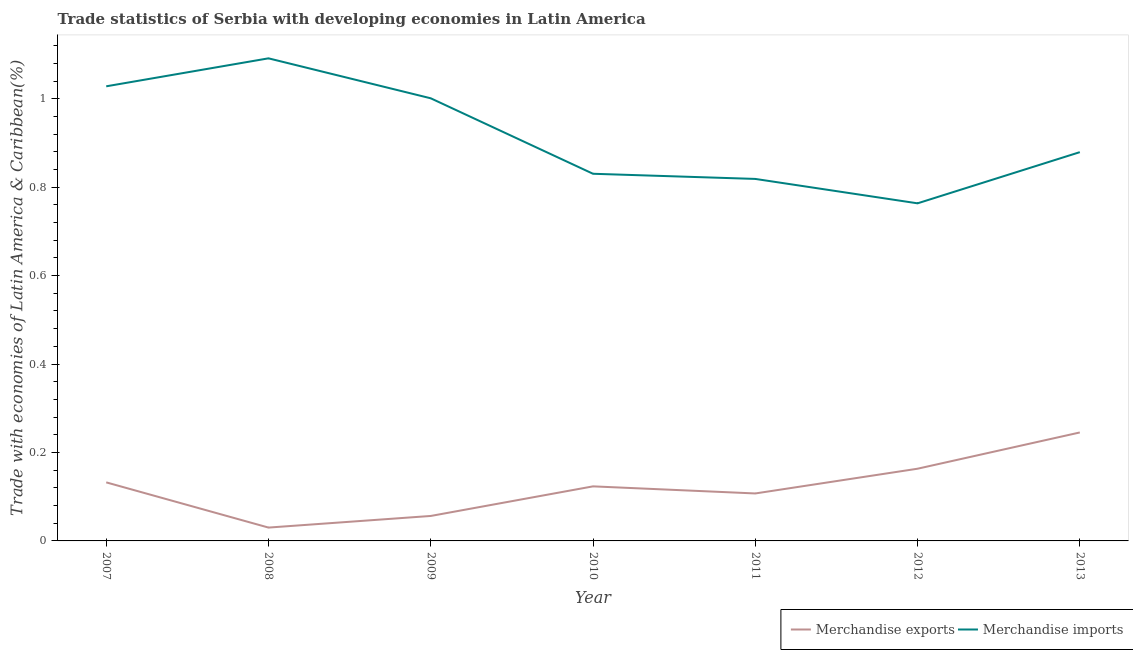Does the line corresponding to merchandise exports intersect with the line corresponding to merchandise imports?
Your response must be concise. No. Is the number of lines equal to the number of legend labels?
Offer a very short reply. Yes. What is the merchandise imports in 2007?
Offer a very short reply. 1.03. Across all years, what is the maximum merchandise exports?
Your answer should be very brief. 0.25. Across all years, what is the minimum merchandise exports?
Make the answer very short. 0.03. In which year was the merchandise imports minimum?
Your answer should be very brief. 2012. What is the total merchandise imports in the graph?
Make the answer very short. 6.41. What is the difference between the merchandise exports in 2011 and that in 2013?
Offer a terse response. -0.14. What is the difference between the merchandise exports in 2013 and the merchandise imports in 2011?
Provide a short and direct response. -0.57. What is the average merchandise exports per year?
Ensure brevity in your answer.  0.12. In the year 2007, what is the difference between the merchandise exports and merchandise imports?
Ensure brevity in your answer.  -0.9. What is the ratio of the merchandise imports in 2010 to that in 2011?
Ensure brevity in your answer.  1.01. What is the difference between the highest and the second highest merchandise exports?
Give a very brief answer. 0.08. What is the difference between the highest and the lowest merchandise imports?
Your answer should be very brief. 0.33. Does the merchandise exports monotonically increase over the years?
Provide a short and direct response. No. Is the merchandise imports strictly greater than the merchandise exports over the years?
Make the answer very short. Yes. Is the merchandise exports strictly less than the merchandise imports over the years?
Offer a very short reply. Yes. How many lines are there?
Provide a short and direct response. 2. How are the legend labels stacked?
Keep it short and to the point. Horizontal. What is the title of the graph?
Make the answer very short. Trade statistics of Serbia with developing economies in Latin America. Does "Net National savings" appear as one of the legend labels in the graph?
Offer a very short reply. No. What is the label or title of the Y-axis?
Provide a succinct answer. Trade with economies of Latin America & Caribbean(%). What is the Trade with economies of Latin America & Caribbean(%) of Merchandise exports in 2007?
Make the answer very short. 0.13. What is the Trade with economies of Latin America & Caribbean(%) in Merchandise imports in 2007?
Offer a terse response. 1.03. What is the Trade with economies of Latin America & Caribbean(%) of Merchandise exports in 2008?
Offer a terse response. 0.03. What is the Trade with economies of Latin America & Caribbean(%) in Merchandise imports in 2008?
Your answer should be very brief. 1.09. What is the Trade with economies of Latin America & Caribbean(%) of Merchandise exports in 2009?
Give a very brief answer. 0.06. What is the Trade with economies of Latin America & Caribbean(%) of Merchandise imports in 2009?
Give a very brief answer. 1. What is the Trade with economies of Latin America & Caribbean(%) of Merchandise exports in 2010?
Your answer should be compact. 0.12. What is the Trade with economies of Latin America & Caribbean(%) in Merchandise imports in 2010?
Ensure brevity in your answer.  0.83. What is the Trade with economies of Latin America & Caribbean(%) of Merchandise exports in 2011?
Ensure brevity in your answer.  0.11. What is the Trade with economies of Latin America & Caribbean(%) in Merchandise imports in 2011?
Keep it short and to the point. 0.82. What is the Trade with economies of Latin America & Caribbean(%) in Merchandise exports in 2012?
Provide a short and direct response. 0.16. What is the Trade with economies of Latin America & Caribbean(%) in Merchandise imports in 2012?
Your answer should be compact. 0.76. What is the Trade with economies of Latin America & Caribbean(%) in Merchandise exports in 2013?
Ensure brevity in your answer.  0.25. What is the Trade with economies of Latin America & Caribbean(%) in Merchandise imports in 2013?
Give a very brief answer. 0.88. Across all years, what is the maximum Trade with economies of Latin America & Caribbean(%) in Merchandise exports?
Your answer should be compact. 0.25. Across all years, what is the maximum Trade with economies of Latin America & Caribbean(%) in Merchandise imports?
Give a very brief answer. 1.09. Across all years, what is the minimum Trade with economies of Latin America & Caribbean(%) in Merchandise exports?
Provide a succinct answer. 0.03. Across all years, what is the minimum Trade with economies of Latin America & Caribbean(%) of Merchandise imports?
Offer a terse response. 0.76. What is the total Trade with economies of Latin America & Caribbean(%) of Merchandise exports in the graph?
Offer a terse response. 0.86. What is the total Trade with economies of Latin America & Caribbean(%) in Merchandise imports in the graph?
Ensure brevity in your answer.  6.41. What is the difference between the Trade with economies of Latin America & Caribbean(%) of Merchandise exports in 2007 and that in 2008?
Your response must be concise. 0.1. What is the difference between the Trade with economies of Latin America & Caribbean(%) of Merchandise imports in 2007 and that in 2008?
Your response must be concise. -0.06. What is the difference between the Trade with economies of Latin America & Caribbean(%) in Merchandise exports in 2007 and that in 2009?
Provide a succinct answer. 0.08. What is the difference between the Trade with economies of Latin America & Caribbean(%) in Merchandise imports in 2007 and that in 2009?
Offer a very short reply. 0.03. What is the difference between the Trade with economies of Latin America & Caribbean(%) in Merchandise exports in 2007 and that in 2010?
Provide a succinct answer. 0.01. What is the difference between the Trade with economies of Latin America & Caribbean(%) in Merchandise imports in 2007 and that in 2010?
Offer a terse response. 0.2. What is the difference between the Trade with economies of Latin America & Caribbean(%) of Merchandise exports in 2007 and that in 2011?
Provide a succinct answer. 0.03. What is the difference between the Trade with economies of Latin America & Caribbean(%) of Merchandise imports in 2007 and that in 2011?
Your answer should be compact. 0.21. What is the difference between the Trade with economies of Latin America & Caribbean(%) in Merchandise exports in 2007 and that in 2012?
Offer a very short reply. -0.03. What is the difference between the Trade with economies of Latin America & Caribbean(%) of Merchandise imports in 2007 and that in 2012?
Offer a very short reply. 0.26. What is the difference between the Trade with economies of Latin America & Caribbean(%) of Merchandise exports in 2007 and that in 2013?
Make the answer very short. -0.11. What is the difference between the Trade with economies of Latin America & Caribbean(%) of Merchandise imports in 2007 and that in 2013?
Provide a succinct answer. 0.15. What is the difference between the Trade with economies of Latin America & Caribbean(%) in Merchandise exports in 2008 and that in 2009?
Provide a succinct answer. -0.03. What is the difference between the Trade with economies of Latin America & Caribbean(%) in Merchandise imports in 2008 and that in 2009?
Offer a terse response. 0.09. What is the difference between the Trade with economies of Latin America & Caribbean(%) in Merchandise exports in 2008 and that in 2010?
Your answer should be compact. -0.09. What is the difference between the Trade with economies of Latin America & Caribbean(%) of Merchandise imports in 2008 and that in 2010?
Your answer should be compact. 0.26. What is the difference between the Trade with economies of Latin America & Caribbean(%) of Merchandise exports in 2008 and that in 2011?
Your response must be concise. -0.08. What is the difference between the Trade with economies of Latin America & Caribbean(%) in Merchandise imports in 2008 and that in 2011?
Provide a short and direct response. 0.27. What is the difference between the Trade with economies of Latin America & Caribbean(%) in Merchandise exports in 2008 and that in 2012?
Provide a succinct answer. -0.13. What is the difference between the Trade with economies of Latin America & Caribbean(%) of Merchandise imports in 2008 and that in 2012?
Your answer should be compact. 0.33. What is the difference between the Trade with economies of Latin America & Caribbean(%) in Merchandise exports in 2008 and that in 2013?
Offer a terse response. -0.22. What is the difference between the Trade with economies of Latin America & Caribbean(%) of Merchandise imports in 2008 and that in 2013?
Ensure brevity in your answer.  0.21. What is the difference between the Trade with economies of Latin America & Caribbean(%) of Merchandise exports in 2009 and that in 2010?
Ensure brevity in your answer.  -0.07. What is the difference between the Trade with economies of Latin America & Caribbean(%) in Merchandise imports in 2009 and that in 2010?
Provide a short and direct response. 0.17. What is the difference between the Trade with economies of Latin America & Caribbean(%) of Merchandise exports in 2009 and that in 2011?
Provide a short and direct response. -0.05. What is the difference between the Trade with economies of Latin America & Caribbean(%) in Merchandise imports in 2009 and that in 2011?
Make the answer very short. 0.18. What is the difference between the Trade with economies of Latin America & Caribbean(%) in Merchandise exports in 2009 and that in 2012?
Offer a very short reply. -0.11. What is the difference between the Trade with economies of Latin America & Caribbean(%) of Merchandise imports in 2009 and that in 2012?
Give a very brief answer. 0.24. What is the difference between the Trade with economies of Latin America & Caribbean(%) of Merchandise exports in 2009 and that in 2013?
Your answer should be compact. -0.19. What is the difference between the Trade with economies of Latin America & Caribbean(%) of Merchandise imports in 2009 and that in 2013?
Keep it short and to the point. 0.12. What is the difference between the Trade with economies of Latin America & Caribbean(%) in Merchandise exports in 2010 and that in 2011?
Your answer should be compact. 0.02. What is the difference between the Trade with economies of Latin America & Caribbean(%) in Merchandise imports in 2010 and that in 2011?
Your answer should be compact. 0.01. What is the difference between the Trade with economies of Latin America & Caribbean(%) in Merchandise exports in 2010 and that in 2012?
Keep it short and to the point. -0.04. What is the difference between the Trade with economies of Latin America & Caribbean(%) of Merchandise imports in 2010 and that in 2012?
Provide a succinct answer. 0.07. What is the difference between the Trade with economies of Latin America & Caribbean(%) in Merchandise exports in 2010 and that in 2013?
Your answer should be very brief. -0.12. What is the difference between the Trade with economies of Latin America & Caribbean(%) in Merchandise imports in 2010 and that in 2013?
Offer a terse response. -0.05. What is the difference between the Trade with economies of Latin America & Caribbean(%) in Merchandise exports in 2011 and that in 2012?
Provide a short and direct response. -0.06. What is the difference between the Trade with economies of Latin America & Caribbean(%) in Merchandise imports in 2011 and that in 2012?
Your response must be concise. 0.06. What is the difference between the Trade with economies of Latin America & Caribbean(%) of Merchandise exports in 2011 and that in 2013?
Keep it short and to the point. -0.14. What is the difference between the Trade with economies of Latin America & Caribbean(%) of Merchandise imports in 2011 and that in 2013?
Offer a terse response. -0.06. What is the difference between the Trade with economies of Latin America & Caribbean(%) of Merchandise exports in 2012 and that in 2013?
Keep it short and to the point. -0.08. What is the difference between the Trade with economies of Latin America & Caribbean(%) of Merchandise imports in 2012 and that in 2013?
Your response must be concise. -0.12. What is the difference between the Trade with economies of Latin America & Caribbean(%) in Merchandise exports in 2007 and the Trade with economies of Latin America & Caribbean(%) in Merchandise imports in 2008?
Make the answer very short. -0.96. What is the difference between the Trade with economies of Latin America & Caribbean(%) of Merchandise exports in 2007 and the Trade with economies of Latin America & Caribbean(%) of Merchandise imports in 2009?
Provide a short and direct response. -0.87. What is the difference between the Trade with economies of Latin America & Caribbean(%) of Merchandise exports in 2007 and the Trade with economies of Latin America & Caribbean(%) of Merchandise imports in 2010?
Ensure brevity in your answer.  -0.7. What is the difference between the Trade with economies of Latin America & Caribbean(%) of Merchandise exports in 2007 and the Trade with economies of Latin America & Caribbean(%) of Merchandise imports in 2011?
Offer a very short reply. -0.69. What is the difference between the Trade with economies of Latin America & Caribbean(%) in Merchandise exports in 2007 and the Trade with economies of Latin America & Caribbean(%) in Merchandise imports in 2012?
Your answer should be very brief. -0.63. What is the difference between the Trade with economies of Latin America & Caribbean(%) of Merchandise exports in 2007 and the Trade with economies of Latin America & Caribbean(%) of Merchandise imports in 2013?
Your response must be concise. -0.75. What is the difference between the Trade with economies of Latin America & Caribbean(%) in Merchandise exports in 2008 and the Trade with economies of Latin America & Caribbean(%) in Merchandise imports in 2009?
Your answer should be very brief. -0.97. What is the difference between the Trade with economies of Latin America & Caribbean(%) of Merchandise exports in 2008 and the Trade with economies of Latin America & Caribbean(%) of Merchandise imports in 2010?
Make the answer very short. -0.8. What is the difference between the Trade with economies of Latin America & Caribbean(%) of Merchandise exports in 2008 and the Trade with economies of Latin America & Caribbean(%) of Merchandise imports in 2011?
Ensure brevity in your answer.  -0.79. What is the difference between the Trade with economies of Latin America & Caribbean(%) in Merchandise exports in 2008 and the Trade with economies of Latin America & Caribbean(%) in Merchandise imports in 2012?
Your answer should be very brief. -0.73. What is the difference between the Trade with economies of Latin America & Caribbean(%) in Merchandise exports in 2008 and the Trade with economies of Latin America & Caribbean(%) in Merchandise imports in 2013?
Give a very brief answer. -0.85. What is the difference between the Trade with economies of Latin America & Caribbean(%) of Merchandise exports in 2009 and the Trade with economies of Latin America & Caribbean(%) of Merchandise imports in 2010?
Make the answer very short. -0.77. What is the difference between the Trade with economies of Latin America & Caribbean(%) in Merchandise exports in 2009 and the Trade with economies of Latin America & Caribbean(%) in Merchandise imports in 2011?
Ensure brevity in your answer.  -0.76. What is the difference between the Trade with economies of Latin America & Caribbean(%) in Merchandise exports in 2009 and the Trade with economies of Latin America & Caribbean(%) in Merchandise imports in 2012?
Provide a succinct answer. -0.71. What is the difference between the Trade with economies of Latin America & Caribbean(%) in Merchandise exports in 2009 and the Trade with economies of Latin America & Caribbean(%) in Merchandise imports in 2013?
Your answer should be very brief. -0.82. What is the difference between the Trade with economies of Latin America & Caribbean(%) in Merchandise exports in 2010 and the Trade with economies of Latin America & Caribbean(%) in Merchandise imports in 2011?
Make the answer very short. -0.7. What is the difference between the Trade with economies of Latin America & Caribbean(%) of Merchandise exports in 2010 and the Trade with economies of Latin America & Caribbean(%) of Merchandise imports in 2012?
Keep it short and to the point. -0.64. What is the difference between the Trade with economies of Latin America & Caribbean(%) of Merchandise exports in 2010 and the Trade with economies of Latin America & Caribbean(%) of Merchandise imports in 2013?
Your response must be concise. -0.76. What is the difference between the Trade with economies of Latin America & Caribbean(%) of Merchandise exports in 2011 and the Trade with economies of Latin America & Caribbean(%) of Merchandise imports in 2012?
Provide a succinct answer. -0.66. What is the difference between the Trade with economies of Latin America & Caribbean(%) of Merchandise exports in 2011 and the Trade with economies of Latin America & Caribbean(%) of Merchandise imports in 2013?
Your response must be concise. -0.77. What is the difference between the Trade with economies of Latin America & Caribbean(%) of Merchandise exports in 2012 and the Trade with economies of Latin America & Caribbean(%) of Merchandise imports in 2013?
Ensure brevity in your answer.  -0.72. What is the average Trade with economies of Latin America & Caribbean(%) in Merchandise exports per year?
Offer a terse response. 0.12. What is the average Trade with economies of Latin America & Caribbean(%) of Merchandise imports per year?
Offer a very short reply. 0.92. In the year 2007, what is the difference between the Trade with economies of Latin America & Caribbean(%) of Merchandise exports and Trade with economies of Latin America & Caribbean(%) of Merchandise imports?
Provide a short and direct response. -0.9. In the year 2008, what is the difference between the Trade with economies of Latin America & Caribbean(%) of Merchandise exports and Trade with economies of Latin America & Caribbean(%) of Merchandise imports?
Your answer should be very brief. -1.06. In the year 2009, what is the difference between the Trade with economies of Latin America & Caribbean(%) in Merchandise exports and Trade with economies of Latin America & Caribbean(%) in Merchandise imports?
Offer a terse response. -0.94. In the year 2010, what is the difference between the Trade with economies of Latin America & Caribbean(%) in Merchandise exports and Trade with economies of Latin America & Caribbean(%) in Merchandise imports?
Your response must be concise. -0.71. In the year 2011, what is the difference between the Trade with economies of Latin America & Caribbean(%) in Merchandise exports and Trade with economies of Latin America & Caribbean(%) in Merchandise imports?
Provide a short and direct response. -0.71. In the year 2012, what is the difference between the Trade with economies of Latin America & Caribbean(%) in Merchandise exports and Trade with economies of Latin America & Caribbean(%) in Merchandise imports?
Give a very brief answer. -0.6. In the year 2013, what is the difference between the Trade with economies of Latin America & Caribbean(%) in Merchandise exports and Trade with economies of Latin America & Caribbean(%) in Merchandise imports?
Offer a terse response. -0.63. What is the ratio of the Trade with economies of Latin America & Caribbean(%) in Merchandise exports in 2007 to that in 2008?
Your response must be concise. 4.39. What is the ratio of the Trade with economies of Latin America & Caribbean(%) of Merchandise imports in 2007 to that in 2008?
Offer a very short reply. 0.94. What is the ratio of the Trade with economies of Latin America & Caribbean(%) in Merchandise exports in 2007 to that in 2009?
Your response must be concise. 2.35. What is the ratio of the Trade with economies of Latin America & Caribbean(%) of Merchandise imports in 2007 to that in 2009?
Your response must be concise. 1.03. What is the ratio of the Trade with economies of Latin America & Caribbean(%) of Merchandise exports in 2007 to that in 2010?
Give a very brief answer. 1.07. What is the ratio of the Trade with economies of Latin America & Caribbean(%) in Merchandise imports in 2007 to that in 2010?
Give a very brief answer. 1.24. What is the ratio of the Trade with economies of Latin America & Caribbean(%) in Merchandise exports in 2007 to that in 2011?
Your answer should be very brief. 1.23. What is the ratio of the Trade with economies of Latin America & Caribbean(%) in Merchandise imports in 2007 to that in 2011?
Offer a terse response. 1.26. What is the ratio of the Trade with economies of Latin America & Caribbean(%) in Merchandise exports in 2007 to that in 2012?
Give a very brief answer. 0.81. What is the ratio of the Trade with economies of Latin America & Caribbean(%) of Merchandise imports in 2007 to that in 2012?
Give a very brief answer. 1.35. What is the ratio of the Trade with economies of Latin America & Caribbean(%) in Merchandise exports in 2007 to that in 2013?
Make the answer very short. 0.54. What is the ratio of the Trade with economies of Latin America & Caribbean(%) of Merchandise imports in 2007 to that in 2013?
Ensure brevity in your answer.  1.17. What is the ratio of the Trade with economies of Latin America & Caribbean(%) in Merchandise exports in 2008 to that in 2009?
Provide a short and direct response. 0.53. What is the ratio of the Trade with economies of Latin America & Caribbean(%) of Merchandise imports in 2008 to that in 2009?
Provide a short and direct response. 1.09. What is the ratio of the Trade with economies of Latin America & Caribbean(%) in Merchandise exports in 2008 to that in 2010?
Your answer should be very brief. 0.24. What is the ratio of the Trade with economies of Latin America & Caribbean(%) of Merchandise imports in 2008 to that in 2010?
Give a very brief answer. 1.31. What is the ratio of the Trade with economies of Latin America & Caribbean(%) in Merchandise exports in 2008 to that in 2011?
Give a very brief answer. 0.28. What is the ratio of the Trade with economies of Latin America & Caribbean(%) of Merchandise imports in 2008 to that in 2011?
Your answer should be very brief. 1.33. What is the ratio of the Trade with economies of Latin America & Caribbean(%) in Merchandise exports in 2008 to that in 2012?
Ensure brevity in your answer.  0.18. What is the ratio of the Trade with economies of Latin America & Caribbean(%) in Merchandise imports in 2008 to that in 2012?
Your answer should be very brief. 1.43. What is the ratio of the Trade with economies of Latin America & Caribbean(%) of Merchandise exports in 2008 to that in 2013?
Keep it short and to the point. 0.12. What is the ratio of the Trade with economies of Latin America & Caribbean(%) in Merchandise imports in 2008 to that in 2013?
Offer a terse response. 1.24. What is the ratio of the Trade with economies of Latin America & Caribbean(%) of Merchandise exports in 2009 to that in 2010?
Offer a very short reply. 0.46. What is the ratio of the Trade with economies of Latin America & Caribbean(%) in Merchandise imports in 2009 to that in 2010?
Your answer should be compact. 1.21. What is the ratio of the Trade with economies of Latin America & Caribbean(%) of Merchandise exports in 2009 to that in 2011?
Your response must be concise. 0.53. What is the ratio of the Trade with economies of Latin America & Caribbean(%) of Merchandise imports in 2009 to that in 2011?
Offer a terse response. 1.22. What is the ratio of the Trade with economies of Latin America & Caribbean(%) of Merchandise exports in 2009 to that in 2012?
Your response must be concise. 0.35. What is the ratio of the Trade with economies of Latin America & Caribbean(%) in Merchandise imports in 2009 to that in 2012?
Your answer should be compact. 1.31. What is the ratio of the Trade with economies of Latin America & Caribbean(%) of Merchandise exports in 2009 to that in 2013?
Provide a succinct answer. 0.23. What is the ratio of the Trade with economies of Latin America & Caribbean(%) of Merchandise imports in 2009 to that in 2013?
Keep it short and to the point. 1.14. What is the ratio of the Trade with economies of Latin America & Caribbean(%) in Merchandise exports in 2010 to that in 2011?
Your response must be concise. 1.15. What is the ratio of the Trade with economies of Latin America & Caribbean(%) of Merchandise imports in 2010 to that in 2011?
Make the answer very short. 1.01. What is the ratio of the Trade with economies of Latin America & Caribbean(%) of Merchandise exports in 2010 to that in 2012?
Provide a short and direct response. 0.76. What is the ratio of the Trade with economies of Latin America & Caribbean(%) of Merchandise imports in 2010 to that in 2012?
Your answer should be compact. 1.09. What is the ratio of the Trade with economies of Latin America & Caribbean(%) of Merchandise exports in 2010 to that in 2013?
Give a very brief answer. 0.5. What is the ratio of the Trade with economies of Latin America & Caribbean(%) of Merchandise imports in 2010 to that in 2013?
Your answer should be compact. 0.94. What is the ratio of the Trade with economies of Latin America & Caribbean(%) in Merchandise exports in 2011 to that in 2012?
Offer a terse response. 0.66. What is the ratio of the Trade with economies of Latin America & Caribbean(%) of Merchandise imports in 2011 to that in 2012?
Make the answer very short. 1.07. What is the ratio of the Trade with economies of Latin America & Caribbean(%) in Merchandise exports in 2011 to that in 2013?
Your response must be concise. 0.44. What is the ratio of the Trade with economies of Latin America & Caribbean(%) of Merchandise imports in 2011 to that in 2013?
Make the answer very short. 0.93. What is the ratio of the Trade with economies of Latin America & Caribbean(%) of Merchandise exports in 2012 to that in 2013?
Offer a very short reply. 0.67. What is the ratio of the Trade with economies of Latin America & Caribbean(%) of Merchandise imports in 2012 to that in 2013?
Provide a succinct answer. 0.87. What is the difference between the highest and the second highest Trade with economies of Latin America & Caribbean(%) of Merchandise exports?
Provide a succinct answer. 0.08. What is the difference between the highest and the second highest Trade with economies of Latin America & Caribbean(%) in Merchandise imports?
Provide a succinct answer. 0.06. What is the difference between the highest and the lowest Trade with economies of Latin America & Caribbean(%) of Merchandise exports?
Your response must be concise. 0.22. What is the difference between the highest and the lowest Trade with economies of Latin America & Caribbean(%) of Merchandise imports?
Give a very brief answer. 0.33. 